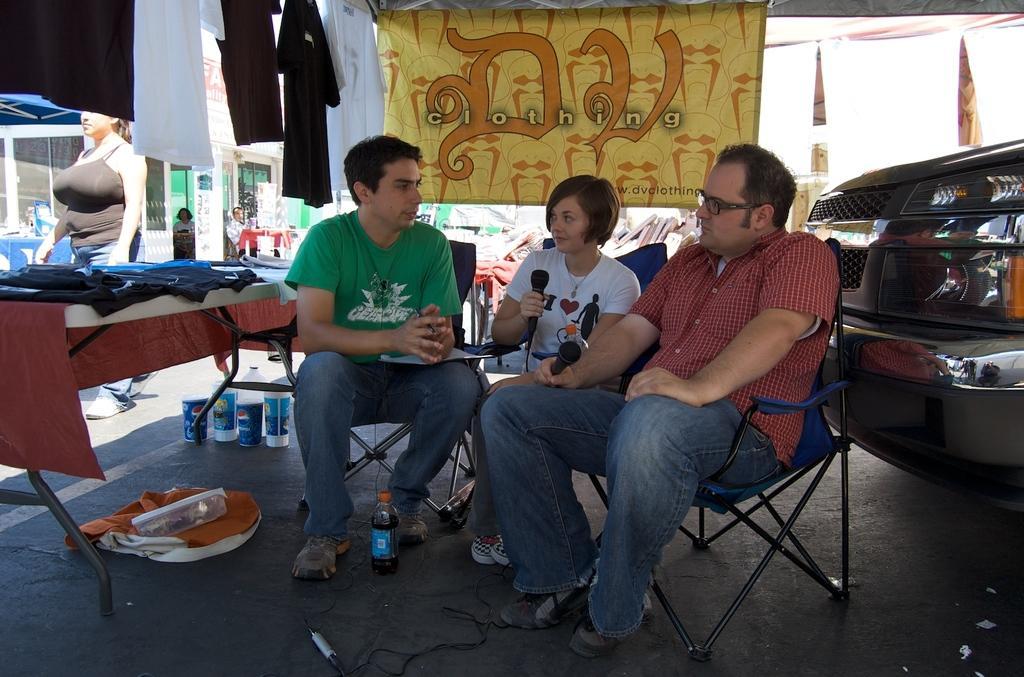Can you describe this image briefly? In this image, In the middle there are some people sitting on the chairs,In the left side there is a table which is covered by a brown color cloth and on that table there are some cloth and in the right side there is a car and in the background there is a yellow color poster. 